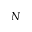Convert formula to latex. <formula><loc_0><loc_0><loc_500><loc_500>N</formula> 